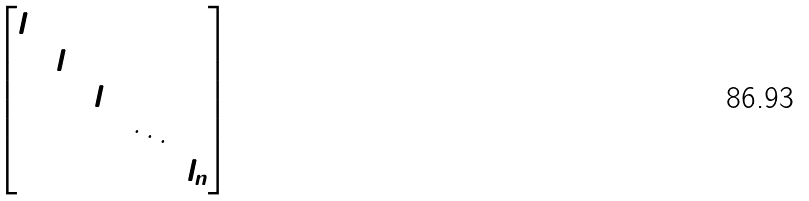Convert formula to latex. <formula><loc_0><loc_0><loc_500><loc_500>\begin{bmatrix} l _ { 1 } & & & & \\ & l _ { 2 } & & & \\ & & l _ { 3 } & & \\ & & & \ddots & \\ & & & & l _ { n } \end{bmatrix}</formula> 